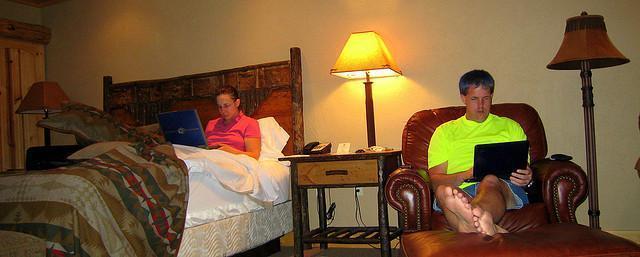How many people are in the room?
Give a very brief answer. 2. How many people are there?
Give a very brief answer. 2. 